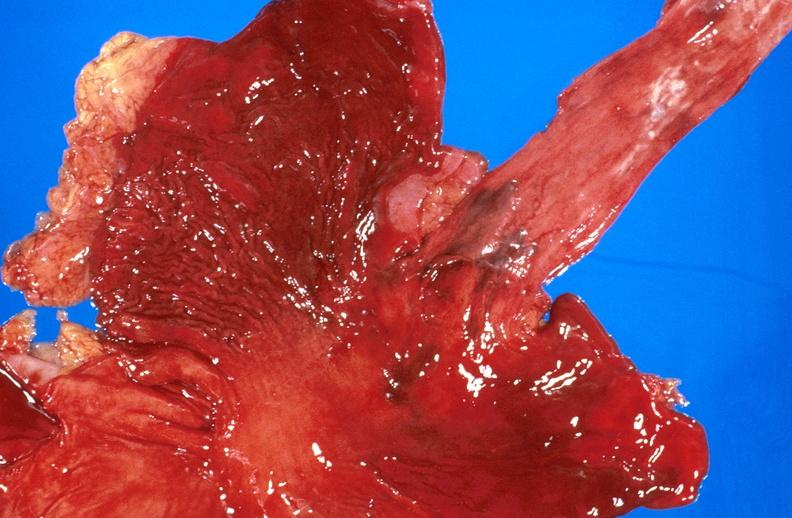where does this belong to?
Answer the question using a single word or phrase. Gastrointestinal system 